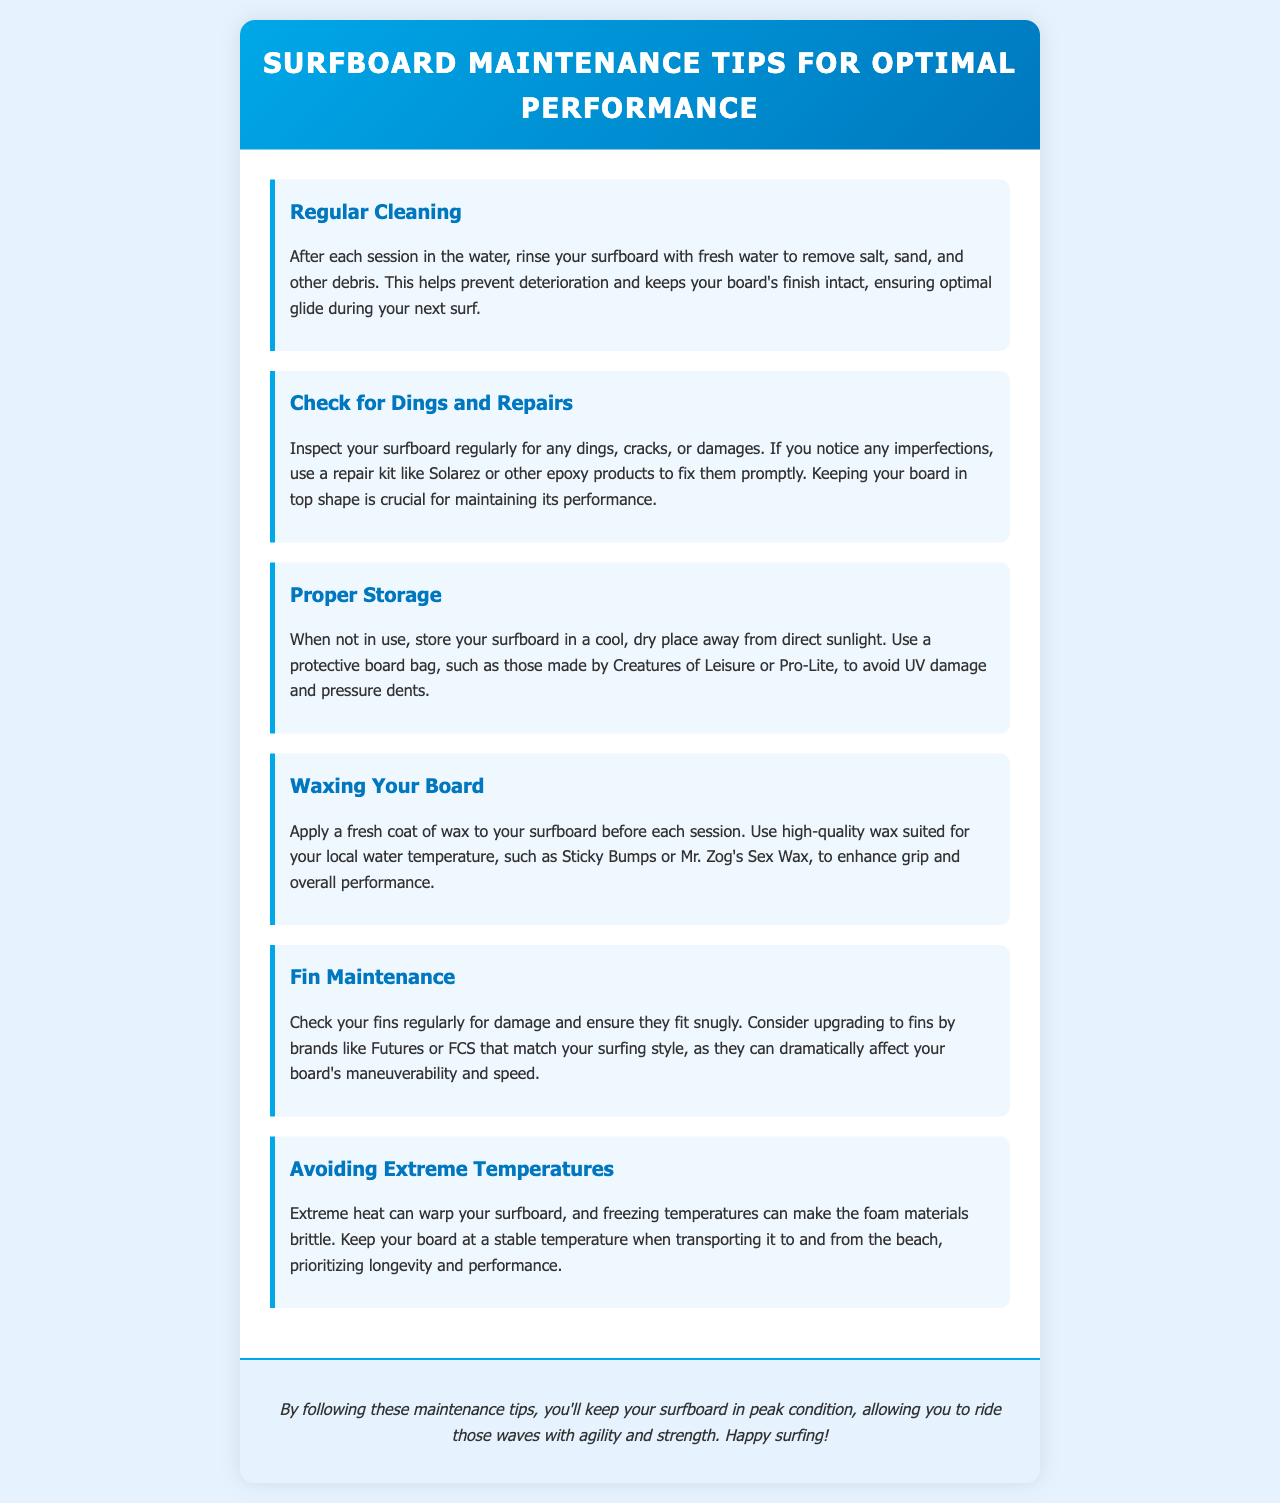What should you do after each session in the water? The document states that you should rinse your surfboard with fresh water to remove salt, sand, and other debris.
Answer: Rinse your surfboard What kind of repair kit can be used for dings? The document mentions using a repair kit like Solarez or other epoxy products to fix dings and damages.
Answer: Solarez What should you use to store your surfboard? According to the document, you should use a protective board bag to store your surfboard.
Answer: Protective board bag What is advised to apply before each surfing session? The document suggests applying a fresh coat of wax to your surfboard before each session.
Answer: Fresh coat of wax Which brands of fins are recommended in the tips? The document recommends upgrading to fins by brands like Futures or FCS.
Answer: Futures or FCS Why is it important to check your fins regularly? The document states it is important to ensure they fit snugly and check for damage to maintain performance.
Answer: To ensure fit and check for damage What temperature conditions should be avoided for your surfboard? The document advises avoiding extreme heat and freezing temperatures to prevent warping or brittleness.
Answer: Extreme heat and freezing temperatures How does rinsing your board help? Rinsing helps to prevent deterioration and keeps the board's finish intact for optimal glide.
Answer: Prevents deterioration What effect can extreme heat have on a surfboard? The document notes that extreme heat can warp your surfboard.
Answer: Warp the surfboard 